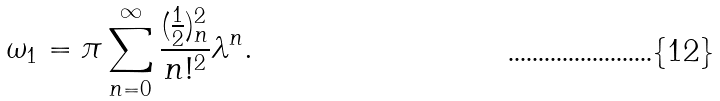<formula> <loc_0><loc_0><loc_500><loc_500>\omega _ { 1 } = \pi \sum _ { n = 0 } ^ { \infty } \frac { ( \frac { 1 } { 2 } ) _ { n } ^ { 2 } } { n ! ^ { 2 } } \lambda ^ { n } .</formula> 